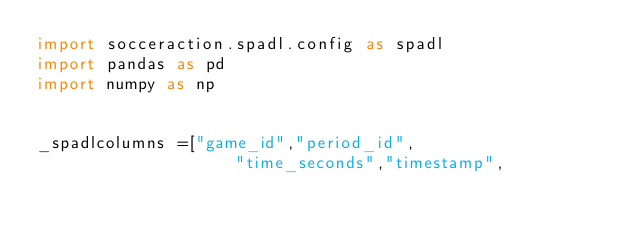Convert code to text. <code><loc_0><loc_0><loc_500><loc_500><_Python_>import socceraction.spadl.config as spadl
import pandas as pd
import numpy as np


_spadlcolumns =["game_id","period_id",
                    "time_seconds","timestamp",</code> 